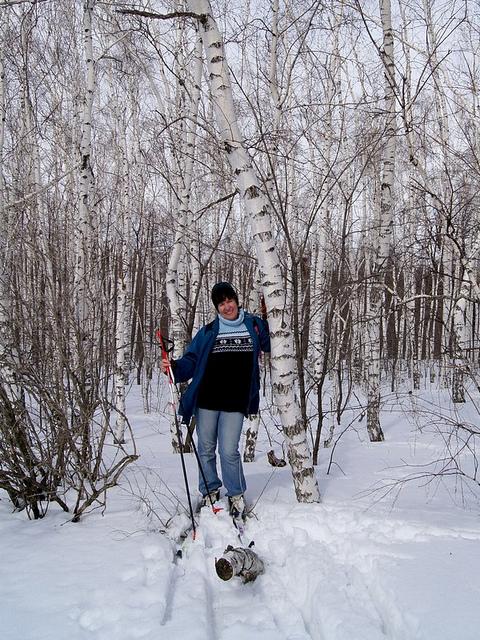Is this picture taken at the beach or in the woods?
Short answer required. Woods. What type of trees is the lady leaning against?
Quick response, please. Birch. What is in the background?
Give a very brief answer. Trees. Name object in front of lady?
Answer briefly. Log. 